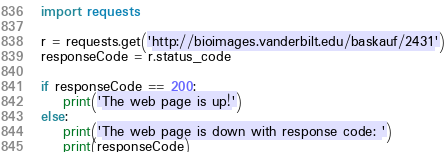<code> <loc_0><loc_0><loc_500><loc_500><_Python_>import requests

r = requests.get('http://bioimages.vanderbilt.edu/baskauf/2431')
responseCode = r.status_code

if responseCode == 200:
    print('The web page is up!')
else:
    print('The web page is down with response code: ')
    print(responseCode)
</code> 